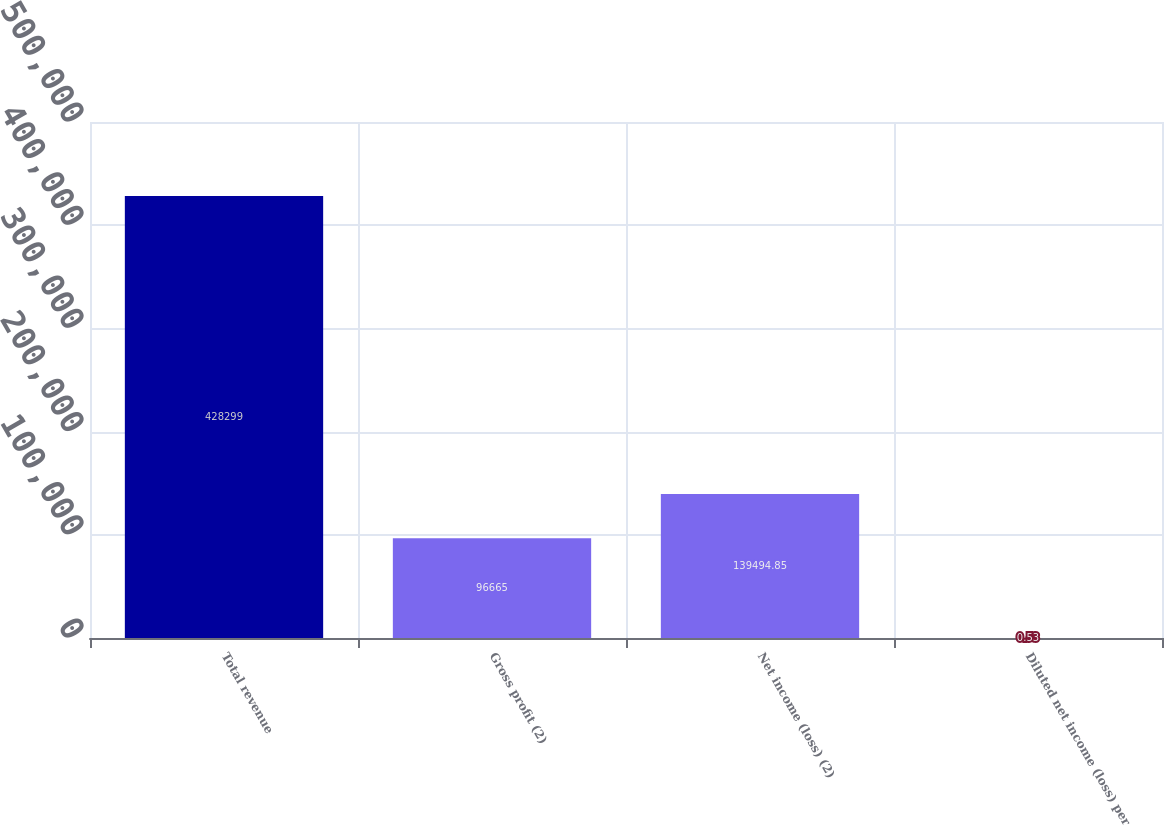<chart> <loc_0><loc_0><loc_500><loc_500><bar_chart><fcel>Total revenue<fcel>Gross profit (2)<fcel>Net income (loss) (2)<fcel>Diluted net income (loss) per<nl><fcel>428299<fcel>96665<fcel>139495<fcel>0.53<nl></chart> 